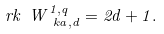<formula> <loc_0><loc_0><loc_500><loc_500>\ r k \ W _ { \ k a , d } ^ { 1 , q } = 2 d + 1 .</formula> 